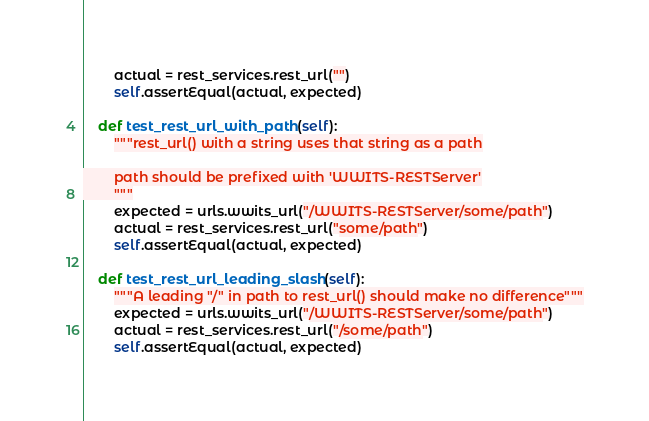Convert code to text. <code><loc_0><loc_0><loc_500><loc_500><_Python_>        actual = rest_services.rest_url("")
        self.assertEqual(actual, expected)

    def test_rest_url_with_path(self):
        """rest_url() with a string uses that string as a path

        path should be prefixed with 'WWITS-RESTServer'
        """
        expected = urls.wwits_url("/WWITS-RESTServer/some/path")
        actual = rest_services.rest_url("some/path")
        self.assertEqual(actual, expected)

    def test_rest_url_leading_slash(self):
        """A leading "/" in path to rest_url() should make no difference"""
        expected = urls.wwits_url("/WWITS-RESTServer/some/path")
        actual = rest_services.rest_url("/some/path")
        self.assertEqual(actual, expected)
</code> 